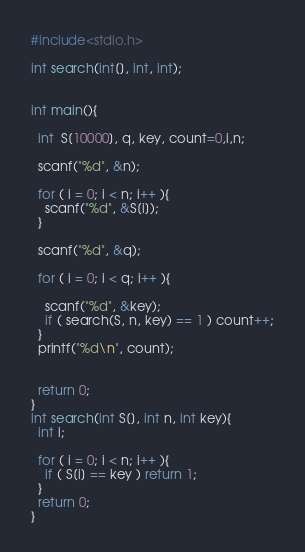<code> <loc_0><loc_0><loc_500><loc_500><_C_>#include<stdio.h>

int search(int[], int, int);


int main(){

  int  S[10000], q, key, count=0,i,n;

  scanf("%d", &n);

  for ( i = 0; i < n; i++ ){ 
    scanf("%d", &S[i]);
  }

  scanf("%d", &q);

  for ( i = 0; i < q; i++ ){
   
    scanf("%d", &key);
    if ( search(S, n, key) == 1 ) count++;
  }
  printf("%d\n", count);


  return 0;
}
int search(int S[], int n, int key){
  int i;

  for ( i = 0; i < n; i++ ){
    if ( S[i] == key ) return 1;
  }
  return 0;
}</code> 